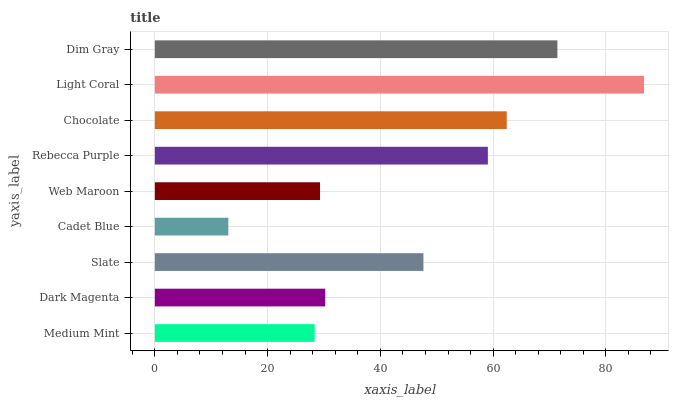Is Cadet Blue the minimum?
Answer yes or no. Yes. Is Light Coral the maximum?
Answer yes or no. Yes. Is Dark Magenta the minimum?
Answer yes or no. No. Is Dark Magenta the maximum?
Answer yes or no. No. Is Dark Magenta greater than Medium Mint?
Answer yes or no. Yes. Is Medium Mint less than Dark Magenta?
Answer yes or no. Yes. Is Medium Mint greater than Dark Magenta?
Answer yes or no. No. Is Dark Magenta less than Medium Mint?
Answer yes or no. No. Is Slate the high median?
Answer yes or no. Yes. Is Slate the low median?
Answer yes or no. Yes. Is Dark Magenta the high median?
Answer yes or no. No. Is Medium Mint the low median?
Answer yes or no. No. 